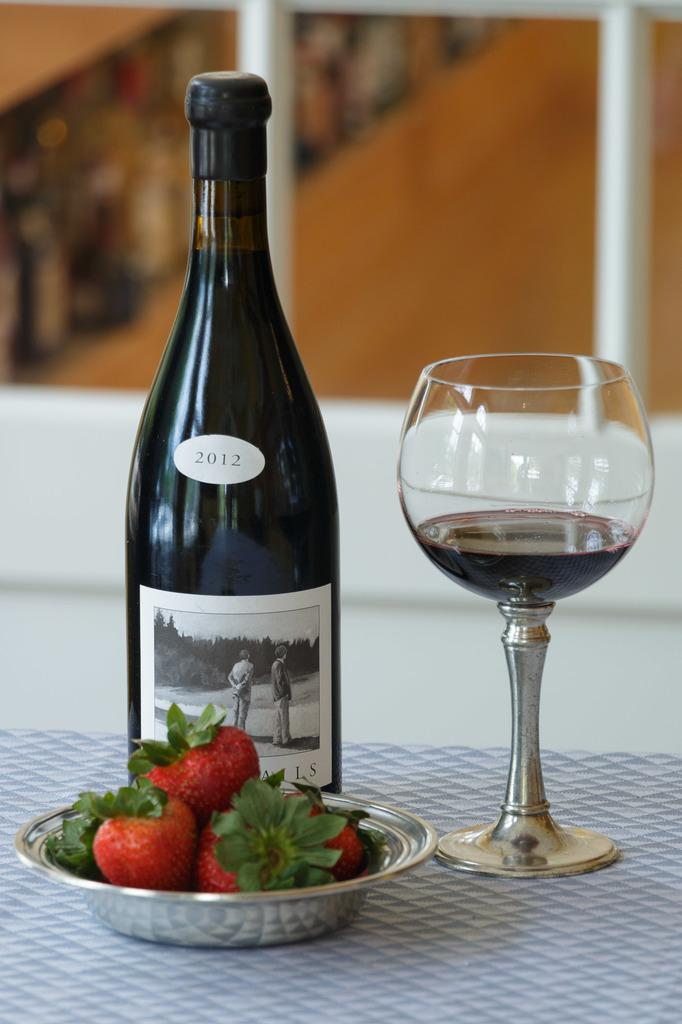What piece of furniture is present in the image? There is a table in the image. What is on the table? There is a wine bottle, a glass of wine, and a plate of strawberries on the table. What type of beverage is in the glass on the table? There is a glass of wine on the table. What type of fruit is on the plate on the table? There is a plate of strawberries on the table. What type of flower is growing on the table in the image? There are no flowers present on the table in the image. 